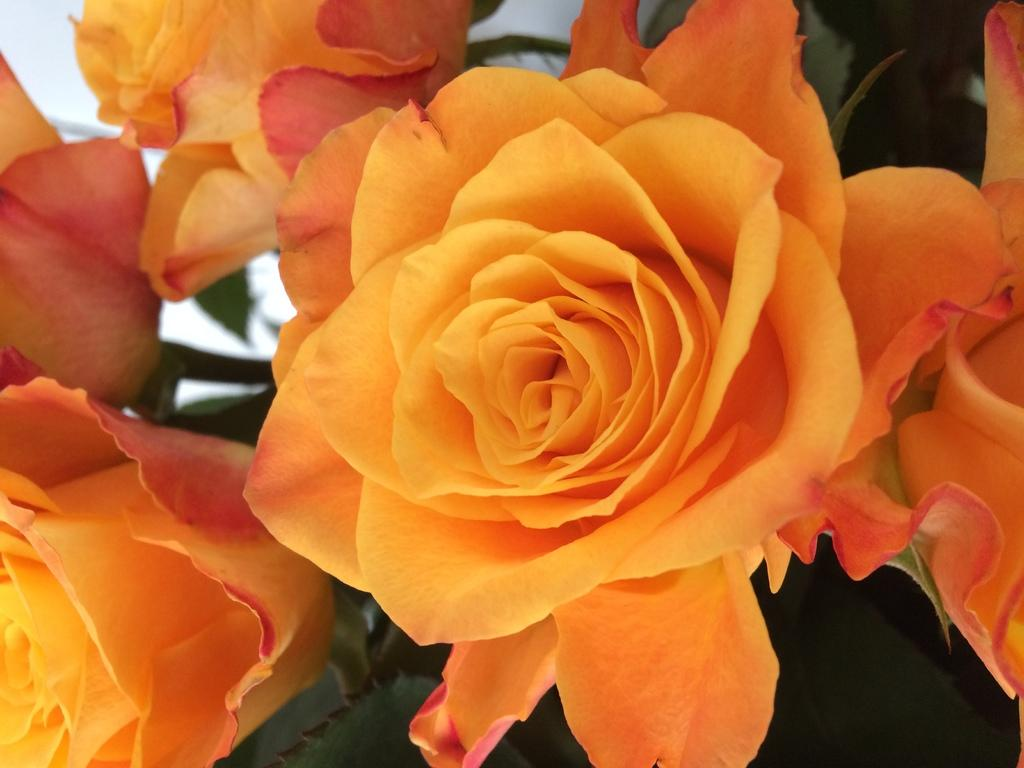What type of plants can be seen in the image? There are flowers in the image. How many cherries are hanging from the flowers in the image? There are no cherries present in the image; it features flowers only. What type of loss is depicted in the image? There is no loss depicted in the image; it features flowers only. 